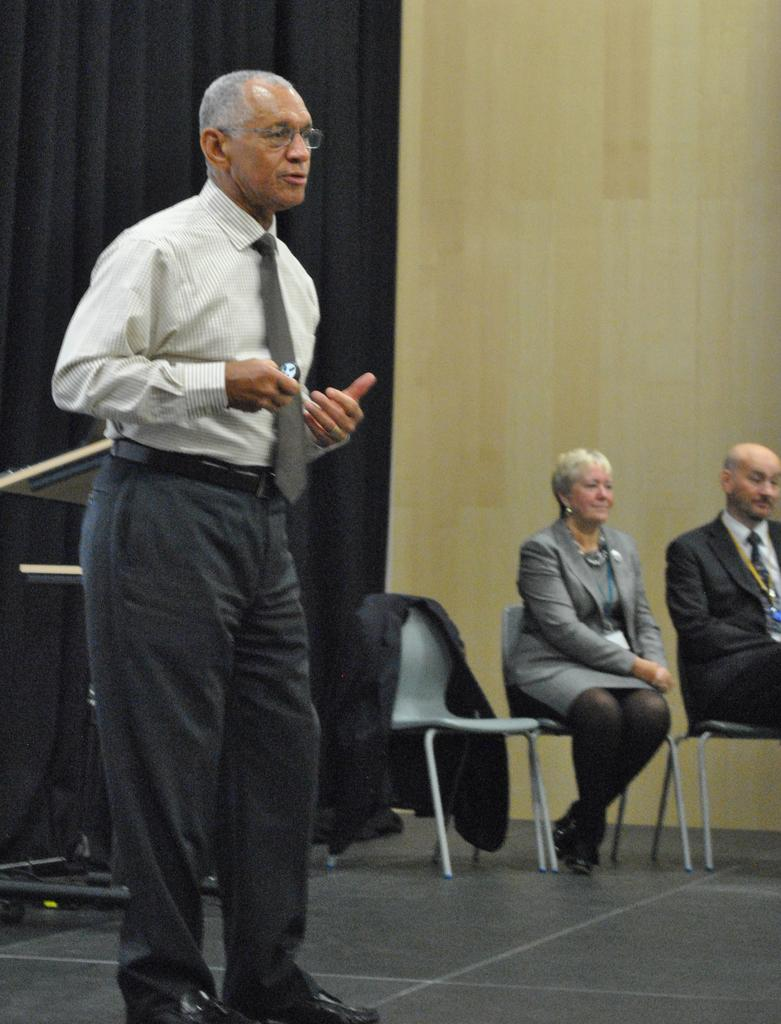How many people are present in the image? There is one person standing and two people seated in the image, making a total of three people. What are the people in the image doing? The information provided does not specify what the people are doing. What can be seen in the background of the image? There are black curtains in the background of the image. What is located on the left side of the image? There is a stand on the left side of the image. What type of umbrella is being used by the person standing in the image? There is no umbrella present in the image. How many arms does the person standing in the image have? The person standing in the image has two arms, as is typical for humans. 